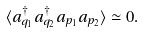Convert formula to latex. <formula><loc_0><loc_0><loc_500><loc_500>\langle a _ { q _ { 1 } } ^ { \dagger } a _ { q _ { 2 } } ^ { \dagger } a _ { p _ { 1 } } a _ { p _ { 2 } } \rangle \simeq 0 .</formula> 